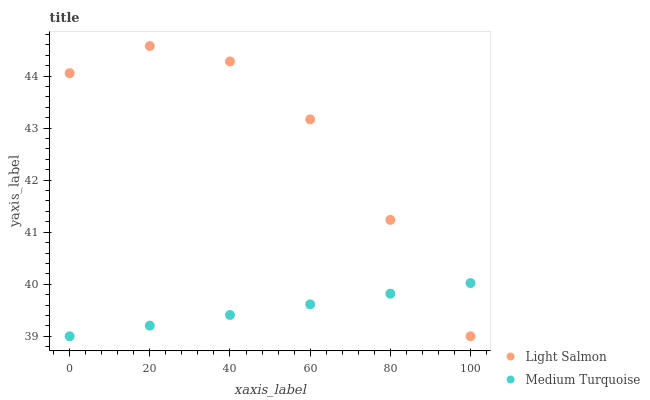Does Medium Turquoise have the minimum area under the curve?
Answer yes or no. Yes. Does Light Salmon have the maximum area under the curve?
Answer yes or no. Yes. Does Medium Turquoise have the maximum area under the curve?
Answer yes or no. No. Is Medium Turquoise the smoothest?
Answer yes or no. Yes. Is Light Salmon the roughest?
Answer yes or no. Yes. Is Medium Turquoise the roughest?
Answer yes or no. No. Does Light Salmon have the lowest value?
Answer yes or no. Yes. Does Light Salmon have the highest value?
Answer yes or no. Yes. Does Medium Turquoise have the highest value?
Answer yes or no. No. Does Light Salmon intersect Medium Turquoise?
Answer yes or no. Yes. Is Light Salmon less than Medium Turquoise?
Answer yes or no. No. Is Light Salmon greater than Medium Turquoise?
Answer yes or no. No. 